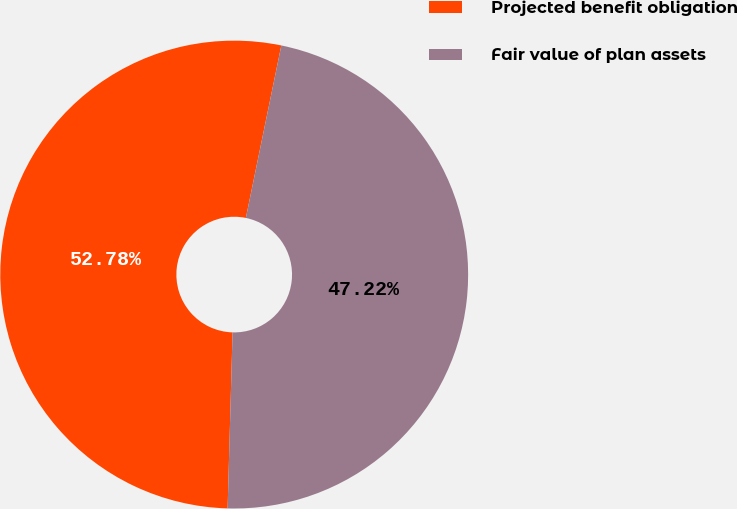<chart> <loc_0><loc_0><loc_500><loc_500><pie_chart><fcel>Projected benefit obligation<fcel>Fair value of plan assets<nl><fcel>52.78%<fcel>47.22%<nl></chart> 